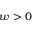<formula> <loc_0><loc_0><loc_500><loc_500>w > 0</formula> 